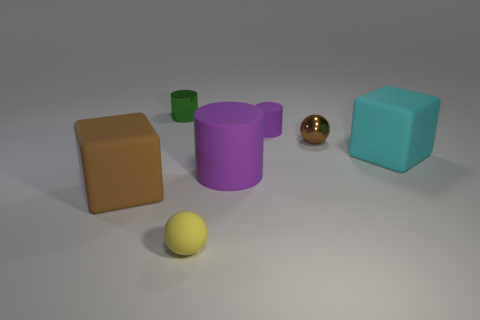Can you tell me the positioning of these objects in relation to one another? Certainly! The objects are arranged on a flat surface spaced out from one another. Starting from the left, there's a brown cube, a small green cylinder, the larger purple cylinder, a reflective golden sphere, and finally, a teal cube to the right. A yellow sphere lies in front of these objects, closer to the foreground of the image. 